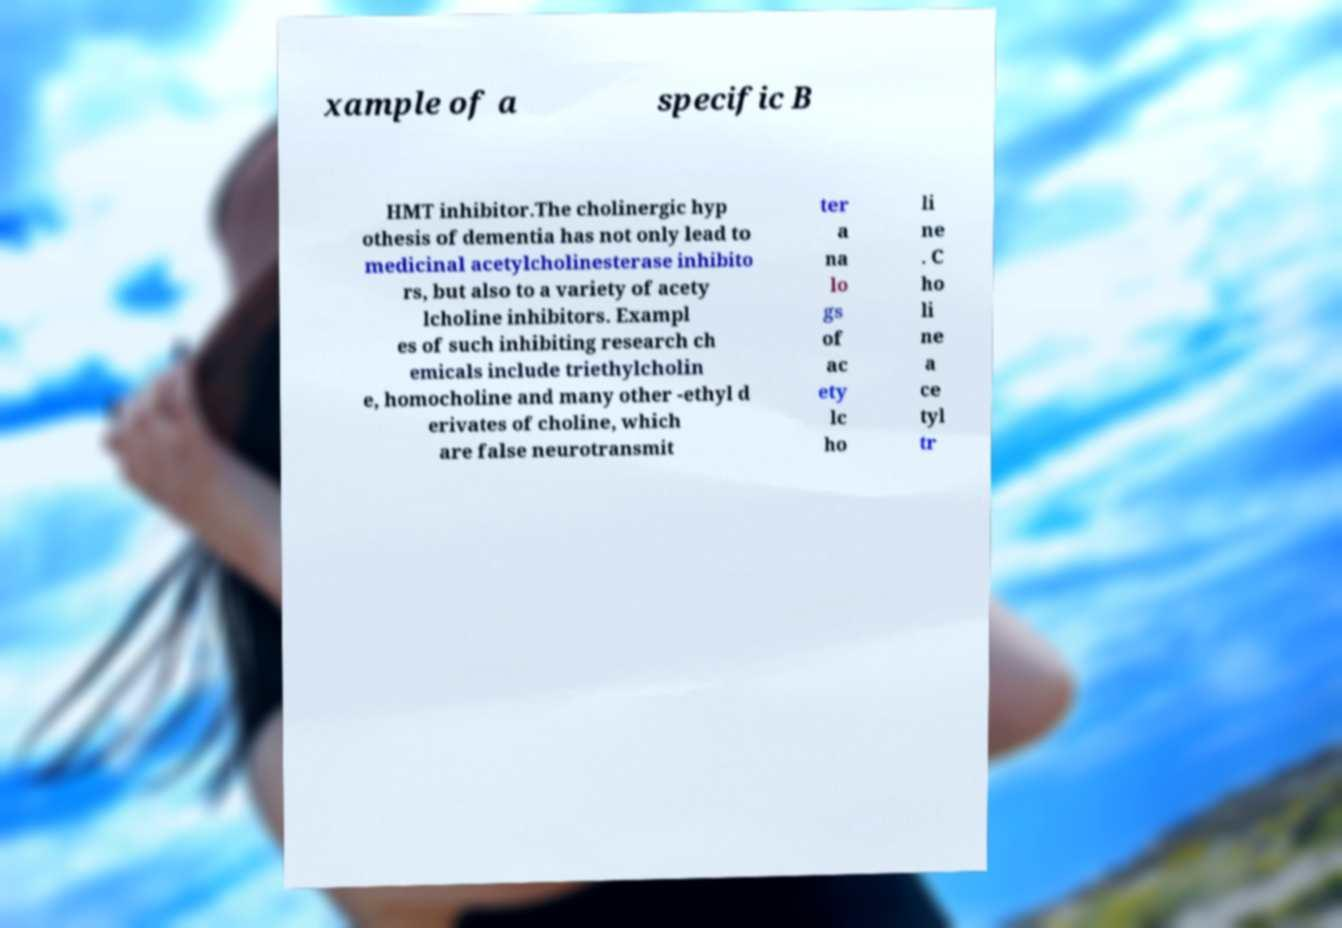Can you read and provide the text displayed in the image?This photo seems to have some interesting text. Can you extract and type it out for me? xample of a specific B HMT inhibitor.The cholinergic hyp othesis of dementia has not only lead to medicinal acetylcholinesterase inhibito rs, but also to a variety of acety lcholine inhibitors. Exampl es of such inhibiting research ch emicals include triethylcholin e, homocholine and many other -ethyl d erivates of choline, which are false neurotransmit ter a na lo gs of ac ety lc ho li ne . C ho li ne a ce tyl tr 